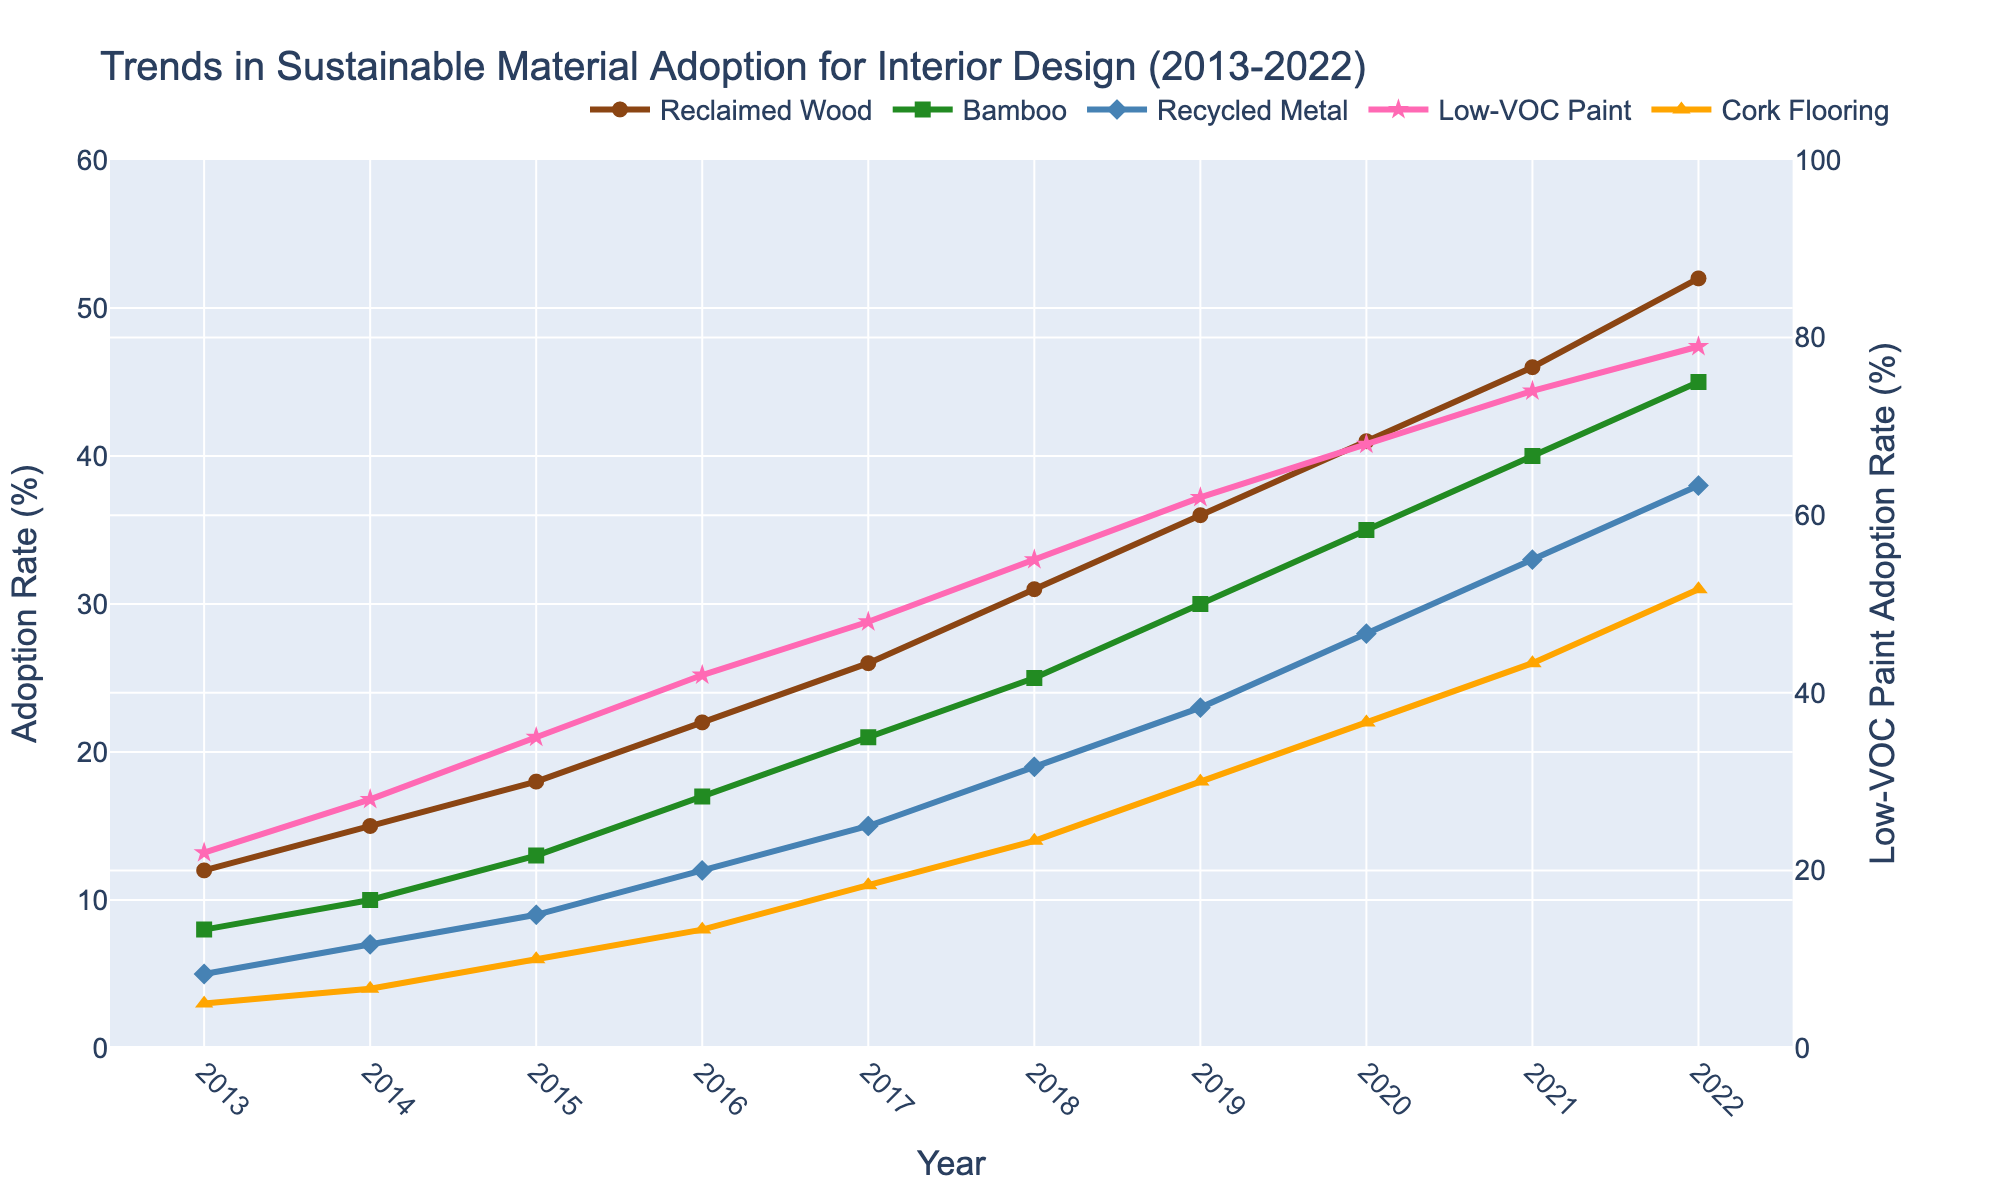Which material had the highest adoption rate in 2022? To answer this, we need to look at the 2022 data for all materials. The adoption rates are: Reclaimed Wood (52%), Bamboo (45%), Recycled Metal (38%), Low-VOC Paint (79%), and Cork Flooring (31%). The highest value is for Low-VOC Paint.
Answer: Low-VOC Paint Which material saw the largest increase in adoption rate from 2013 to 2022? Calculate the difference between the 2022 and 2013 values for each material. The differences are: Reclaimed Wood (52% - 12% = 40%), Bamboo (45% - 8% = 37%), Recycled Metal (38% - 5% = 33%), Low-VOC Paint (79% - 22% = 57%), and Cork Flooring (31% - 3% = 28%). The largest increase is for Low-VOC Paint.
Answer: Low-VOC Paint How does the adoption rate of Reclaimed Wood in 2020 compare to Bamboo in 2020? Look at the 2020 values for both materials. Reclaimed Wood is 41%, and Bamboo is 35%. So, Reclaimed Wood has a higher adoption rate.
Answer: Reclaimed Wood is higher What was the average adoption rate of Recycled Metal from 2013 to 2022? Sum the yearly adoption rates of Recycled Metal and divide by the number of years. The sum is 5 + 7 + 9 + 12 + 15 + 19 + 23 + 28 + 33 + 38 = 189. Divide by 10 (number of years): 189 / 10 = 18.9%.
Answer: 18.9% In which year did Cork Flooring exceed a 20% adoption rate? Examine the yearly data for Cork Flooring and find the first year where the value exceeds 20%. Cork Flooring adoption was 22% in 2020, which is the first value above 20%.
Answer: 2020 Compare the trends of Low-VOC Paint and Recycled Metal: did both show the same trend in 2015 and 2016? In 2015, Low-VOC Paint rose from 28% to 35%, and Recycled Metal rose from 7% to 9%. In 2016, Low-VOC Paint rose from 35% to 42%, and Recycled Metal rose from 9% to 12%. Both materials show an increasing trend for these years.
Answer: Both increased Which material consistently had the lowest adoption rate across the years? By examining the yearly data, Cork Flooring consistently has the lowest adoption rates when compared to the other materials.
Answer: Cork Flooring What was the difference in adoption rate between Bamboo and Cork Flooring in 2017? In 2017, Bamboo had an adoption rate of 21%, while Cork Flooring's was 11%. The difference is 21% - 11% = 10%.
Answer: 10% What was the total adoption rate of all materials in 2013? Sum the adoption rates of all materials for 2013: 12% (Reclaimed Wood) + 8% (Bamboo) + 5% (Recycled Metal) + 22% (Low-VOC Paint) + 3% (Cork Flooring) = 50%.
Answer: 50% By how much did the adoption rate of Low-VOC Paint increase between 2018 and 2022? In 2018, Low-VOC Paint had an adoption rate of 55%, and it increased to 79% by 2022. The increase is 79% - 55% = 24%.
Answer: 24% 